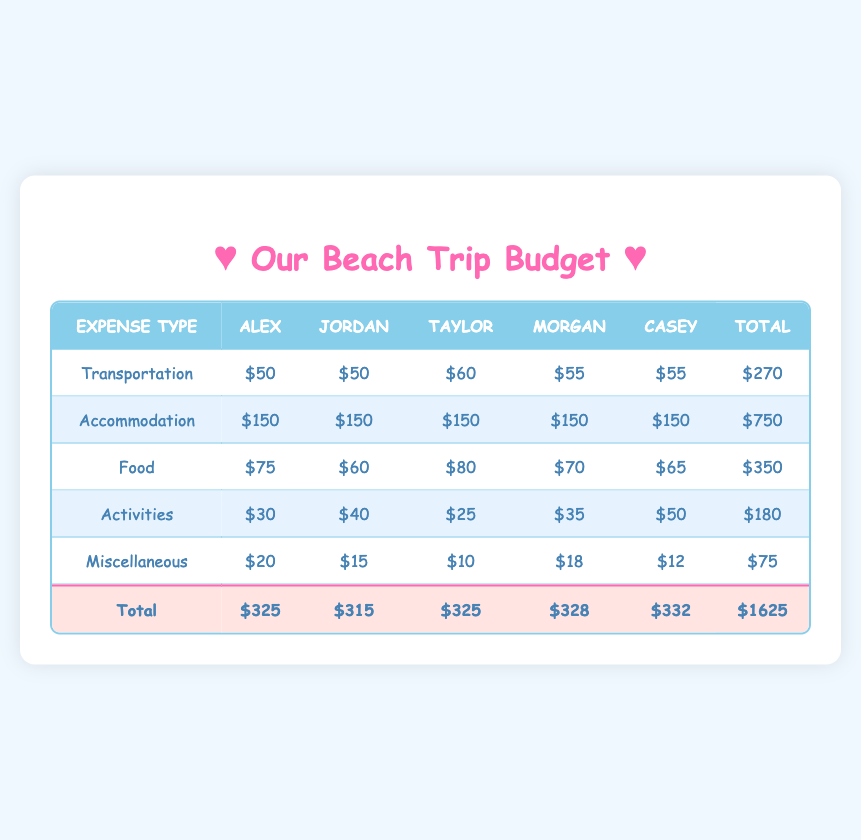What is the total transportation expense for the group? The total value for transportation in the table is provided in the last column under the "Transportation" row. It is $270.
Answer: 270 How much did Taylor spend on food? The "Food" row is examined for Taylor's column, which shows a value of $80.
Answer: 80 Did Jordan spend more on activities than Morgan? Comparing the values in the "Activities" row, Jordan's expense is $40 and Morgan's is $35. Since $40 > $35, the answer is yes.
Answer: Yes What is the average accommodation expense per participant? The total accommodation expense is $750, and there are 5 participants. Dividing $750 by 5 gives the average: 750/5 = 150.
Answer: 150 Which participant had the highest total expense? The total expenses for each participant are as follows: Alex $325, Jordan $315, Taylor $325, Morgan $328, Casey $332. Casey has the highest expense at $332.
Answer: Casey What is the difference between the highest and lowest food expenses? The highest food expense is $80 (Taylor) and the lowest is $60 (Jordan). Calculating the difference gives $80 - $60 = $20.
Answer: 20 Which expense category had the highest total? By examining the total values for each category, Accommodation totals $750, which is higher than the other categories.
Answer: Accommodation If we exclude the miscellaneous expenses, what is the new grand total? The original grand total is $1625. The miscellaneous total is $75, so excluding it: $1625 - $75 = $1550.
Answer: 1550 How many participants spent less than $70 on food? Looking at the food expenses, only Jordan ($60) and Morgan ($70) are below $70. Therefore, there are two participants in total who fall under this category.
Answer: 2 